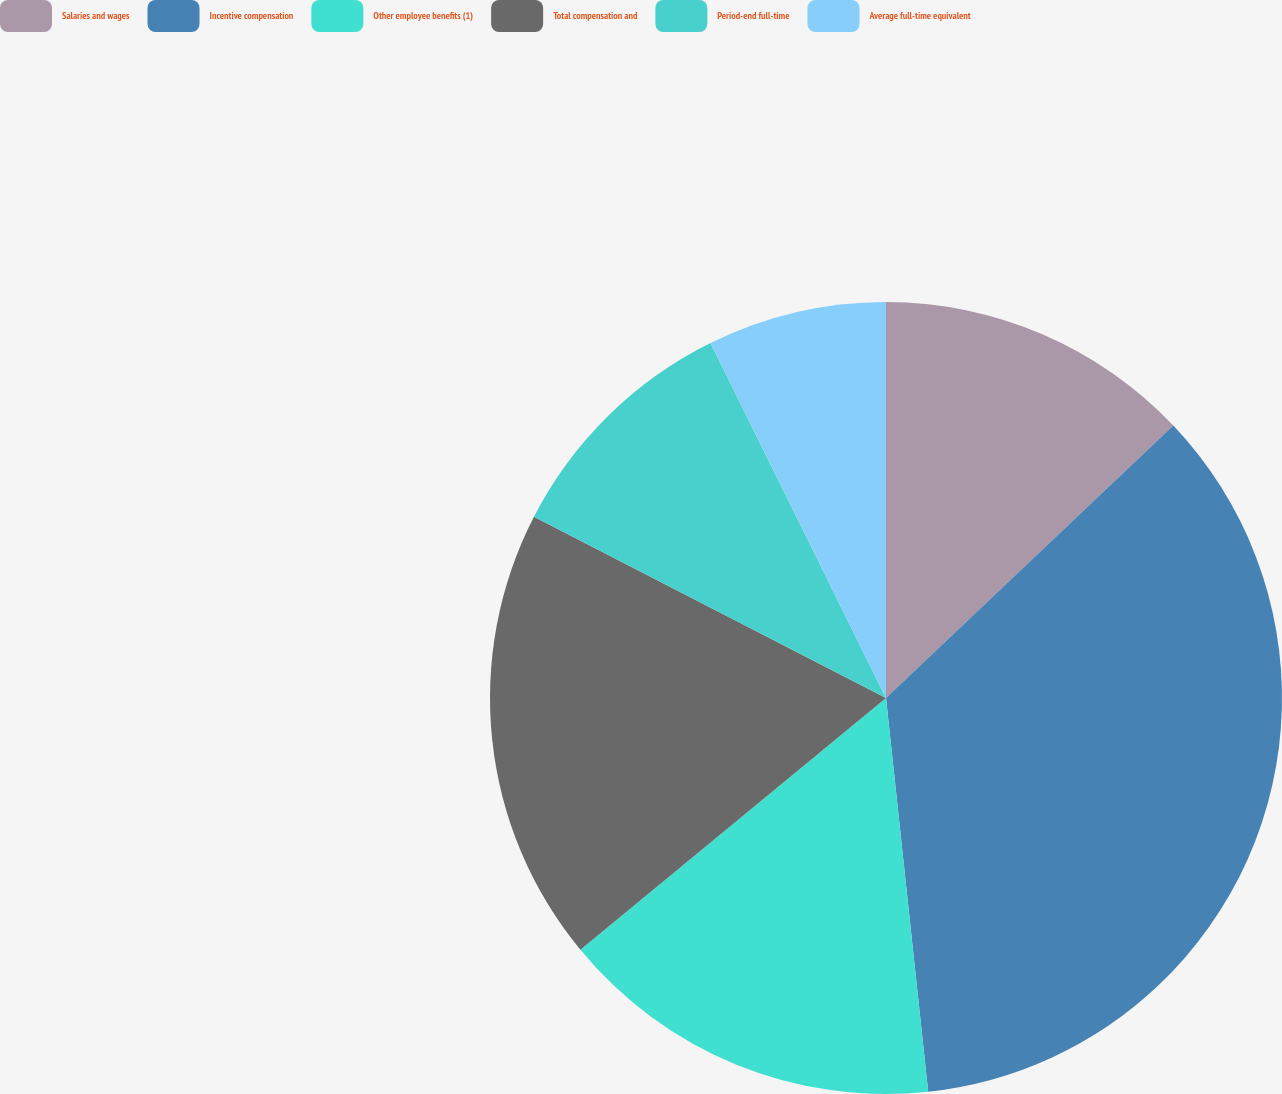Convert chart. <chart><loc_0><loc_0><loc_500><loc_500><pie_chart><fcel>Salaries and wages<fcel>Incentive compensation<fcel>Other employee benefits (1)<fcel>Total compensation and<fcel>Period-end full-time<fcel>Average full-time equivalent<nl><fcel>12.92%<fcel>35.38%<fcel>15.73%<fcel>18.54%<fcel>10.12%<fcel>7.31%<nl></chart> 